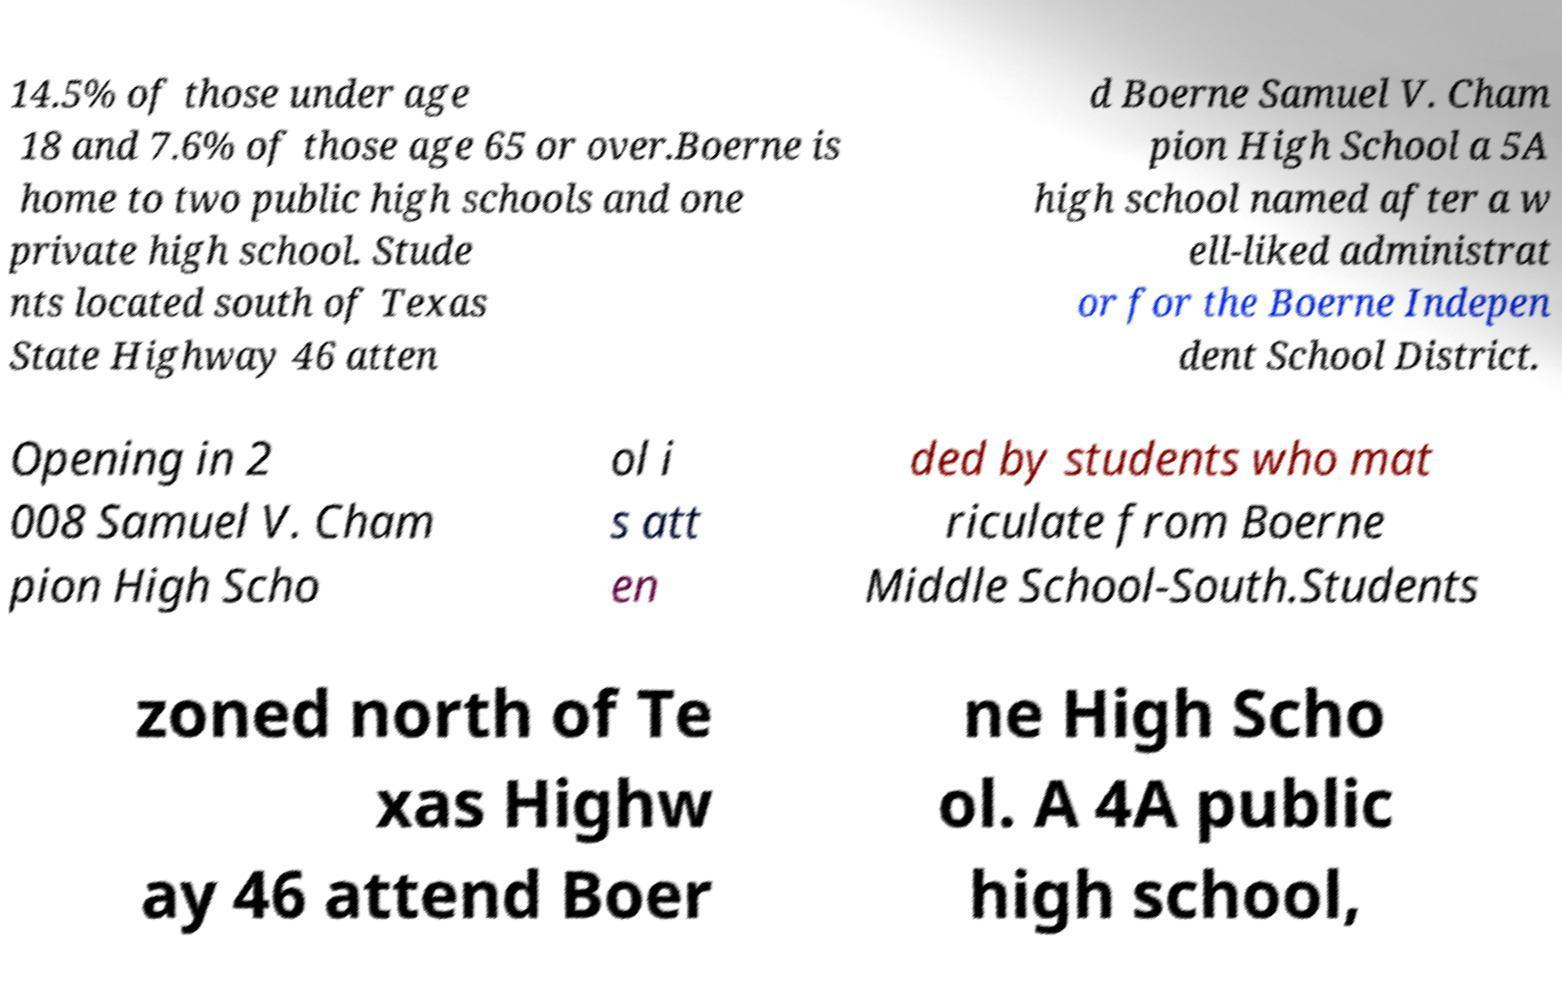There's text embedded in this image that I need extracted. Can you transcribe it verbatim? 14.5% of those under age 18 and 7.6% of those age 65 or over.Boerne is home to two public high schools and one private high school. Stude nts located south of Texas State Highway 46 atten d Boerne Samuel V. Cham pion High School a 5A high school named after a w ell-liked administrat or for the Boerne Indepen dent School District. Opening in 2 008 Samuel V. Cham pion High Scho ol i s att en ded by students who mat riculate from Boerne Middle School-South.Students zoned north of Te xas Highw ay 46 attend Boer ne High Scho ol. A 4A public high school, 